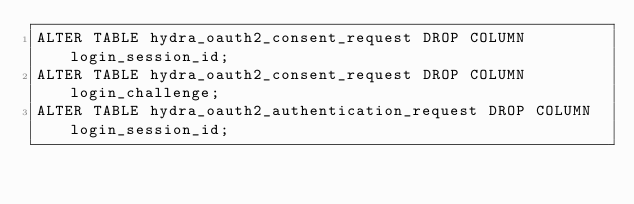Convert code to text. <code><loc_0><loc_0><loc_500><loc_500><_SQL_>ALTER TABLE hydra_oauth2_consent_request DROP COLUMN login_session_id;
ALTER TABLE hydra_oauth2_consent_request DROP COLUMN login_challenge;
ALTER TABLE hydra_oauth2_authentication_request DROP COLUMN login_session_id;
</code> 